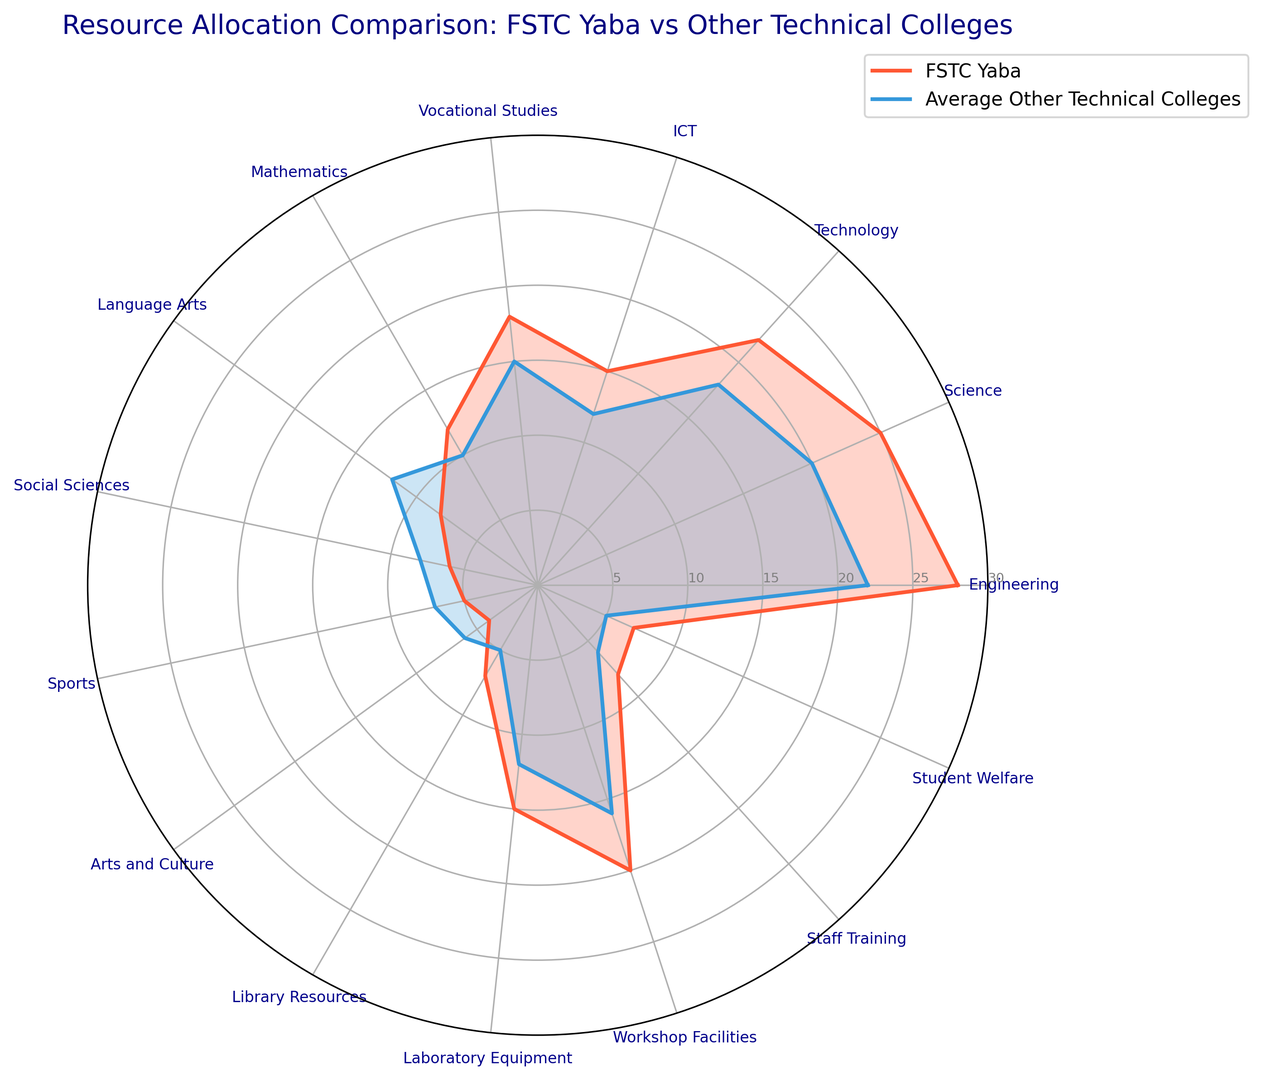Which department at FSTC Yaba shows the largest allocation difference compared to the average of other technical colleges? By observing the figure, the difference between the values for FSTC Yaba and the average of other technical colleges is largest in the Engineering department, where FSTC Yaba has a significantly higher allocation.
Answer: Engineering Which department has equal resource allocation for both FSTC Yaba and the average of other technical colleges? Observing the figure, there is no department where the resource allocation for FSTC Yaba and the average of other technical colleges are equal; they are different across all categories.
Answer: None How many departments have more resource allocation in FSTC Yaba compared to the average of other technical colleges? By counting the number of departments where the orange line (FSTC Yaba) is outside the blue line (average of other technical colleges), we find that there are 12 such departments: Engineering, Science, Technology, ICT, Vocational Studies, Mathematics, Library Resources, Laboratory Equipment, Workshop Facilities, Staff Training, Student Welfare, and Sports.
Answer: 12 Which three departments have the largest resource allocation differences favoring FSTC Yaba? By examining the departments with the largest visual difference between the lines, the three departments where FSTC Yaba has the largest advantage are Engineering, Science, and Technology.
Answer: Engineering, Science, Technology In which two departments do other technical colleges exceed FSTC Yaba in resource allocation? By observing the figure where the blue line exceeds the orange line, the two departments are Language Arts and Social Sciences.
Answer: Language Arts, Social Sciences What is the combined resource allocation for ICT and Laboratory Equipment in FSTC Yaba? From the data, adding the allocations for ICT (15) and Laboratory Equipment (15), the combined resource allocation is 30.
Answer: 30 Which department shows the smallest resource allocation at FSTC Yaba? By looking at the figure, the department with the smallest visual height for FSTC Yaba is Arts and Culture with an allocation of 4.
Answer: Arts and Culture What is the average allocation for the departments that FSTC Yaba allocates more resources to, compared to the average of other technical colleges? Calculating the average: Resource allocations are (28, 25, 22, 15, 18, 12, 7, 15, 20, 8, 7). Sum these values and divide by the number of departments: (177/11) = 16.09.
Answer: 16.09 Which department at FSTC Yaba has the closest resource allocation to the average of other technical colleges in Mathematics? By observing the data, Mathematics at FSTC Yaba is 12, and the closest department allocation to this value is also Mathematics at the average other technical colleges with a 2-point difference.
Answer: Mathematics 